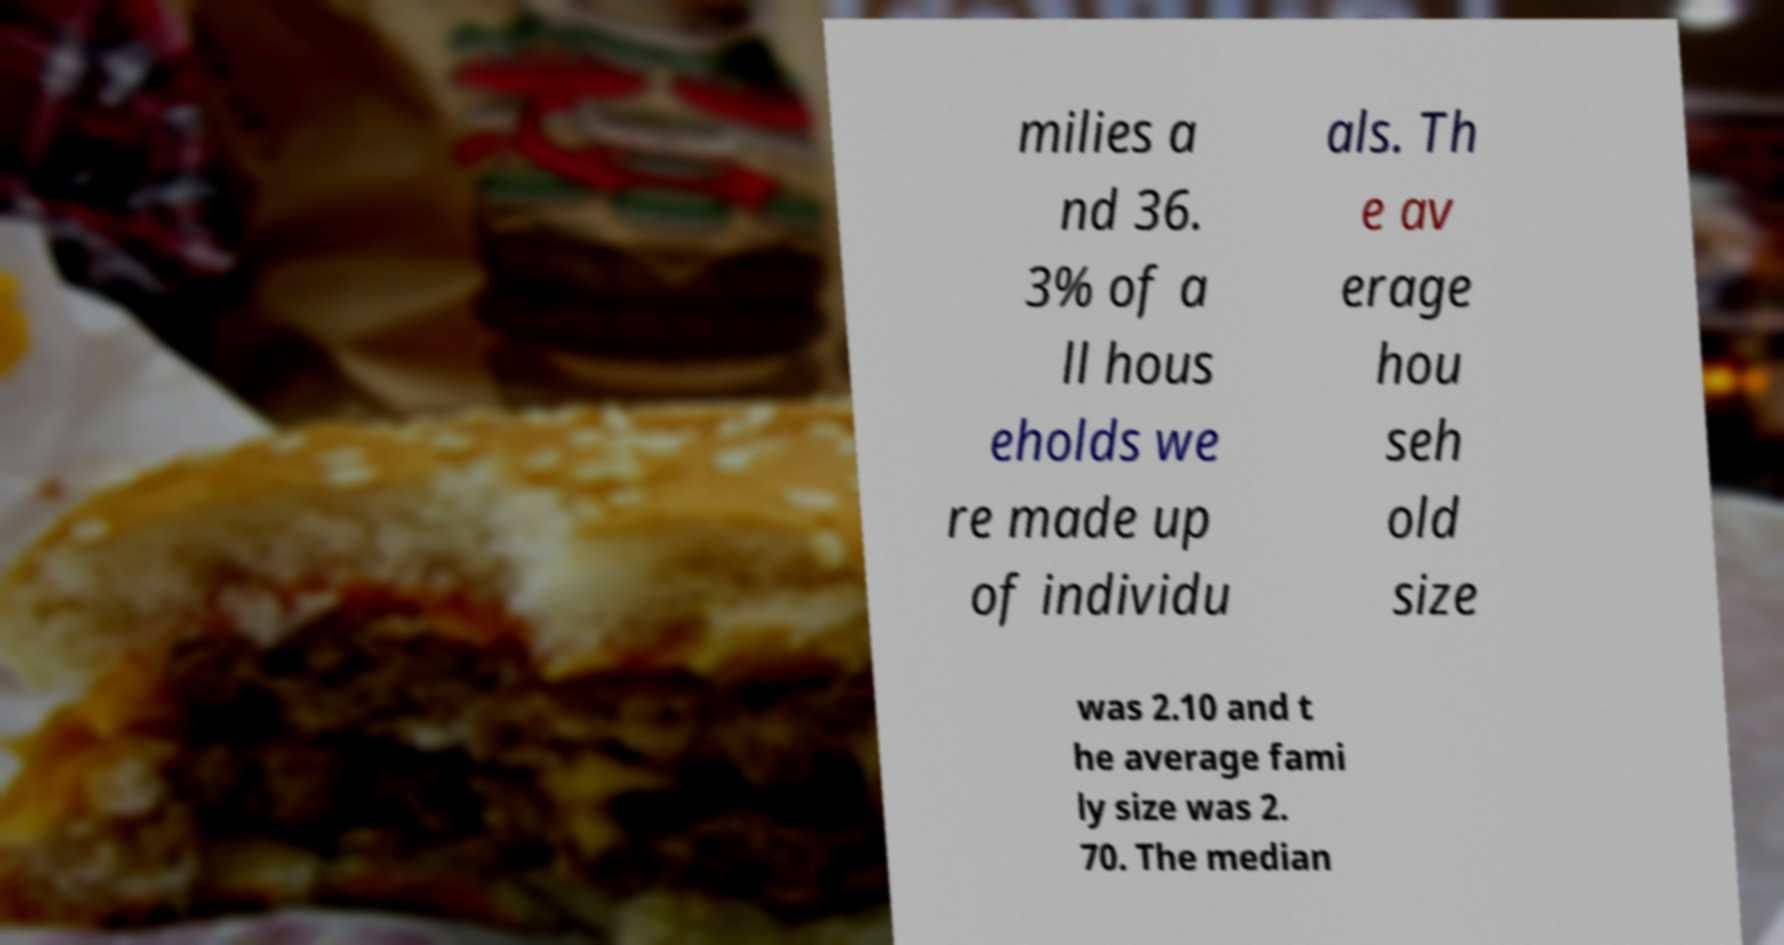Please read and relay the text visible in this image. What does it say? milies a nd 36. 3% of a ll hous eholds we re made up of individu als. Th e av erage hou seh old size was 2.10 and t he average fami ly size was 2. 70. The median 